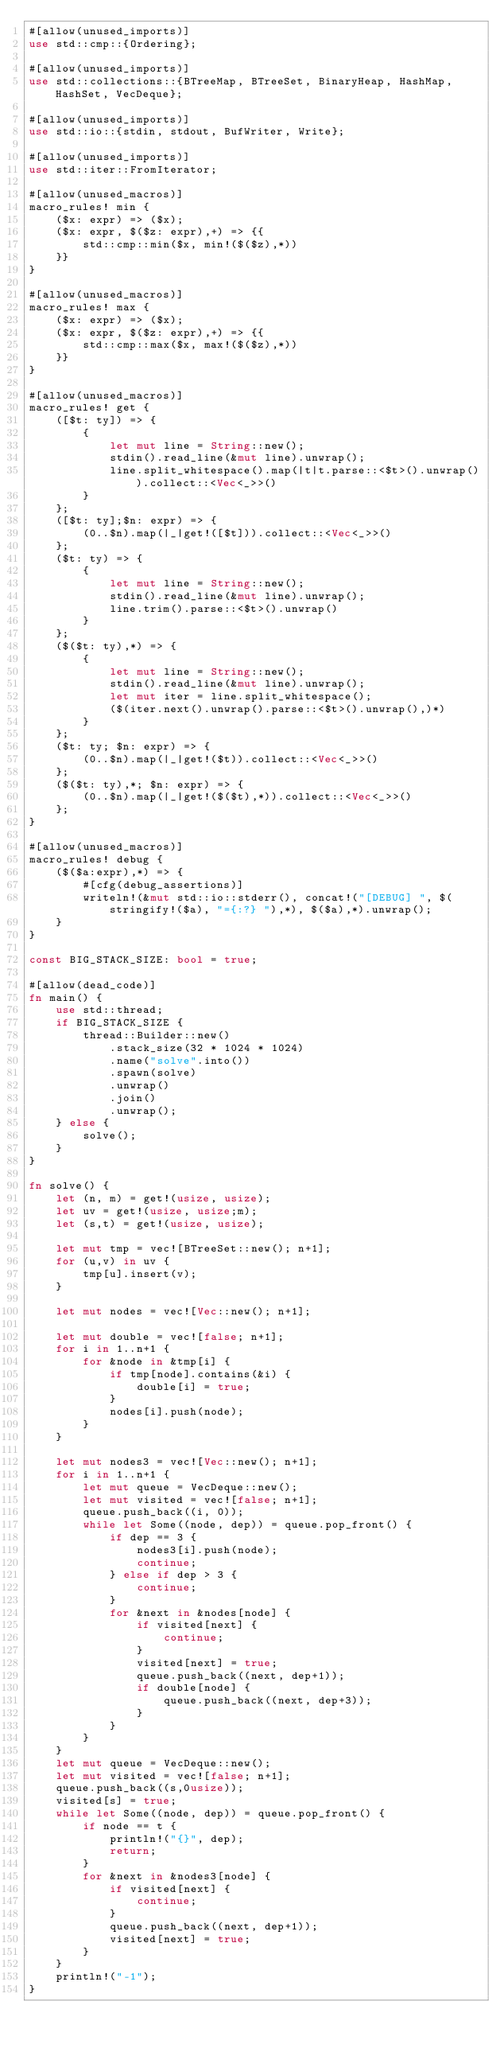Convert code to text. <code><loc_0><loc_0><loc_500><loc_500><_Rust_>#[allow(unused_imports)]
use std::cmp::{Ordering};

#[allow(unused_imports)]
use std::collections::{BTreeMap, BTreeSet, BinaryHeap, HashMap, HashSet, VecDeque};

#[allow(unused_imports)]
use std::io::{stdin, stdout, BufWriter, Write};

#[allow(unused_imports)]
use std::iter::FromIterator;

#[allow(unused_macros)]
macro_rules! min {
    ($x: expr) => ($x);
    ($x: expr, $($z: expr),+) => {{
        std::cmp::min($x, min!($($z),*))
    }}
}

#[allow(unused_macros)]
macro_rules! max {
    ($x: expr) => ($x);
    ($x: expr, $($z: expr),+) => {{
        std::cmp::max($x, max!($($z),*))
    }}
}

#[allow(unused_macros)]
macro_rules! get { 
    ([$t: ty]) => { 
        { 
            let mut line = String::new(); 
            stdin().read_line(&mut line).unwrap(); 
            line.split_whitespace().map(|t|t.parse::<$t>().unwrap()).collect::<Vec<_>>()
        }
    };
    ([$t: ty];$n: expr) => {
        (0..$n).map(|_|get!([$t])).collect::<Vec<_>>()
    };
    ($t: ty) => {
        {
            let mut line = String::new();
            stdin().read_line(&mut line).unwrap();
            line.trim().parse::<$t>().unwrap()
        }
    };
    ($($t: ty),*) => {
        { 
            let mut line = String::new();
            stdin().read_line(&mut line).unwrap();
            let mut iter = line.split_whitespace();
            ($(iter.next().unwrap().parse::<$t>().unwrap(),)*)
        }
    };
    ($t: ty; $n: expr) => {
        (0..$n).map(|_|get!($t)).collect::<Vec<_>>()
    };
    ($($t: ty),*; $n: expr) => {
        (0..$n).map(|_|get!($($t),*)).collect::<Vec<_>>()
    };
}

#[allow(unused_macros)]
macro_rules! debug {
    ($($a:expr),*) => {
        #[cfg(debug_assertions)]
        writeln!(&mut std::io::stderr(), concat!("[DEBUG] ", $(stringify!($a), "={:?} "),*), $($a),*).unwrap();
    }
}

const BIG_STACK_SIZE: bool = true;

#[allow(dead_code)]
fn main() {
    use std::thread;
    if BIG_STACK_SIZE {
        thread::Builder::new()
            .stack_size(32 * 1024 * 1024)
            .name("solve".into())
            .spawn(solve)
            .unwrap()
            .join()
            .unwrap();
    } else {
        solve();
    }
}

fn solve() {
    let (n, m) = get!(usize, usize);
    let uv = get!(usize, usize;m);
    let (s,t) = get!(usize, usize);

    let mut tmp = vec![BTreeSet::new(); n+1];
    for (u,v) in uv {
        tmp[u].insert(v);
    }

    let mut nodes = vec![Vec::new(); n+1];

    let mut double = vec![false; n+1];
    for i in 1..n+1 {
        for &node in &tmp[i] {
            if tmp[node].contains(&i) {
                double[i] = true;
            }
            nodes[i].push(node);
        }
    }

    let mut nodes3 = vec![Vec::new(); n+1];
    for i in 1..n+1 {
        let mut queue = VecDeque::new();
        let mut visited = vec![false; n+1];
        queue.push_back((i, 0));
        while let Some((node, dep)) = queue.pop_front() {
            if dep == 3 {
                nodes3[i].push(node);
                continue;
            } else if dep > 3 {
                continue;
            }
            for &next in &nodes[node] {
                if visited[next] {
                    continue;
                }
                visited[next] = true;
                queue.push_back((next, dep+1));
                if double[node] {
                    queue.push_back((next, dep+3));
                }
            }
        }
    }
    let mut queue = VecDeque::new();
    let mut visited = vec![false; n+1];
    queue.push_back((s,0usize));
    visited[s] = true;
    while let Some((node, dep)) = queue.pop_front() {
        if node == t {
            println!("{}", dep);
            return;
        }
        for &next in &nodes3[node] {
            if visited[next] {
                continue;
            }
            queue.push_back((next, dep+1));
            visited[next] = true;
        }
    }
    println!("-1");
}
</code> 